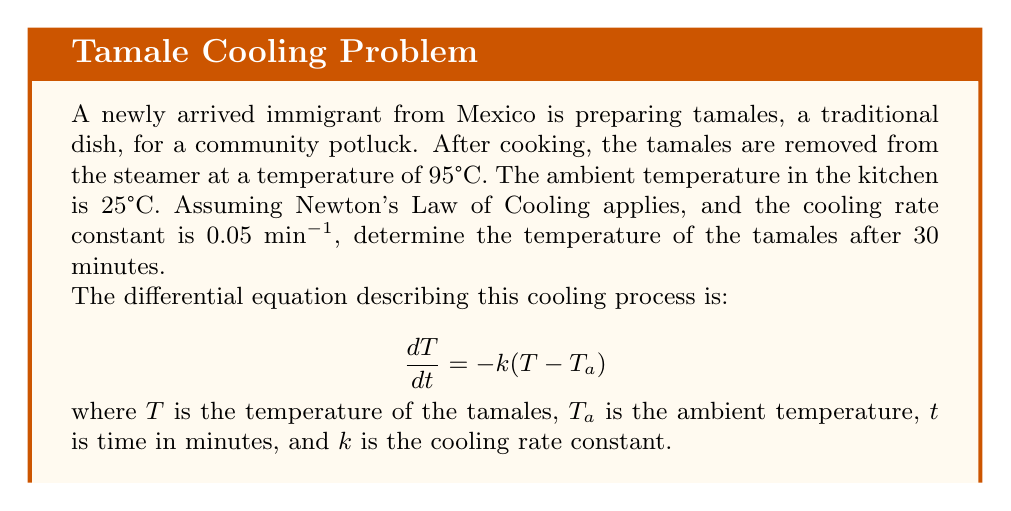Give your solution to this math problem. Let's solve this problem step by step:

1) First, we need to solve the differential equation. The general solution is:

   $$T = T_a + (T_0 - T_a)e^{-kt}$$

   where $T_0$ is the initial temperature.

2) We know the following values:
   $T_0 = 95°C$ (initial temperature)
   $T_a = 25°C$ (ambient temperature)
   $k = 0.05$ min⁻¹ (cooling rate constant)
   $t = 30$ min (time elapsed)

3) Let's substitute these values into our equation:

   $$T = 25 + (95 - 25)e^{-0.05(30)}$$

4) Simplify:
   $$T = 25 + 70e^{-1.5}$$

5) Calculate $e^{-1.5}$:
   $$e^{-1.5} \approx 0.2231$$

6) Now we can finish our calculation:
   $$T = 25 + 70(0.2231)$$
   $$T = 25 + 15.617$$
   $$T = 40.617°C$$

7) Rounding to one decimal place:
   $$T \approx 40.6°C$$
Answer: 40.6°C 